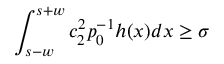<formula> <loc_0><loc_0><loc_500><loc_500>\int _ { s - w } ^ { s + w } c _ { 2 } ^ { 2 } p _ { 0 } ^ { - 1 } h ( x ) d x \geq \sigma</formula> 